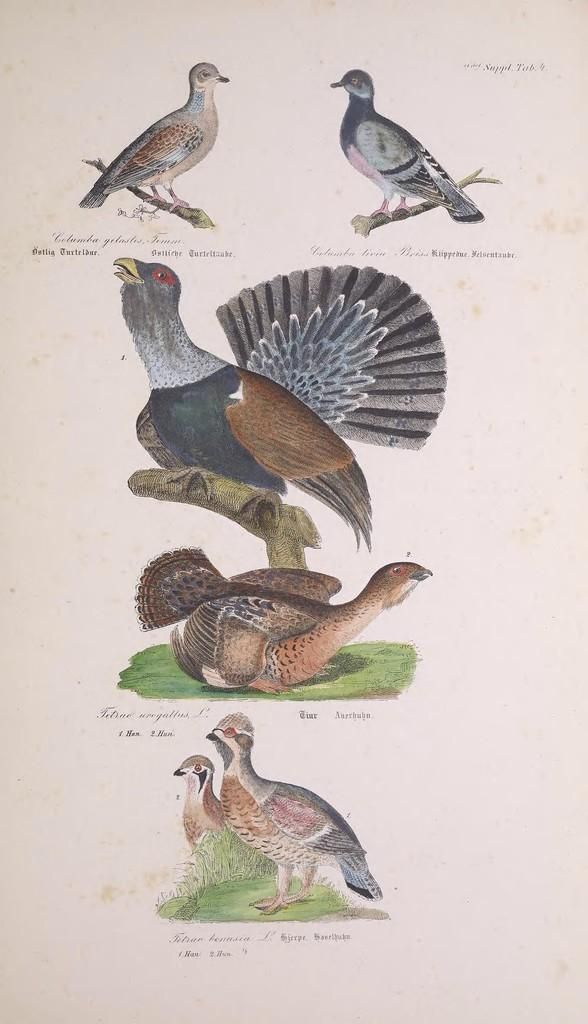What type of medium is the image a part of? The image appears to be a page in a book. What can be seen in the illustrations on the page? There are different birds depicted on the page. Is there any written content on the page? Yes, there is text on the page. What type of amusement can be seen in the image? There is no amusement depicted in the image; it features different birds and text on a page in a book. 